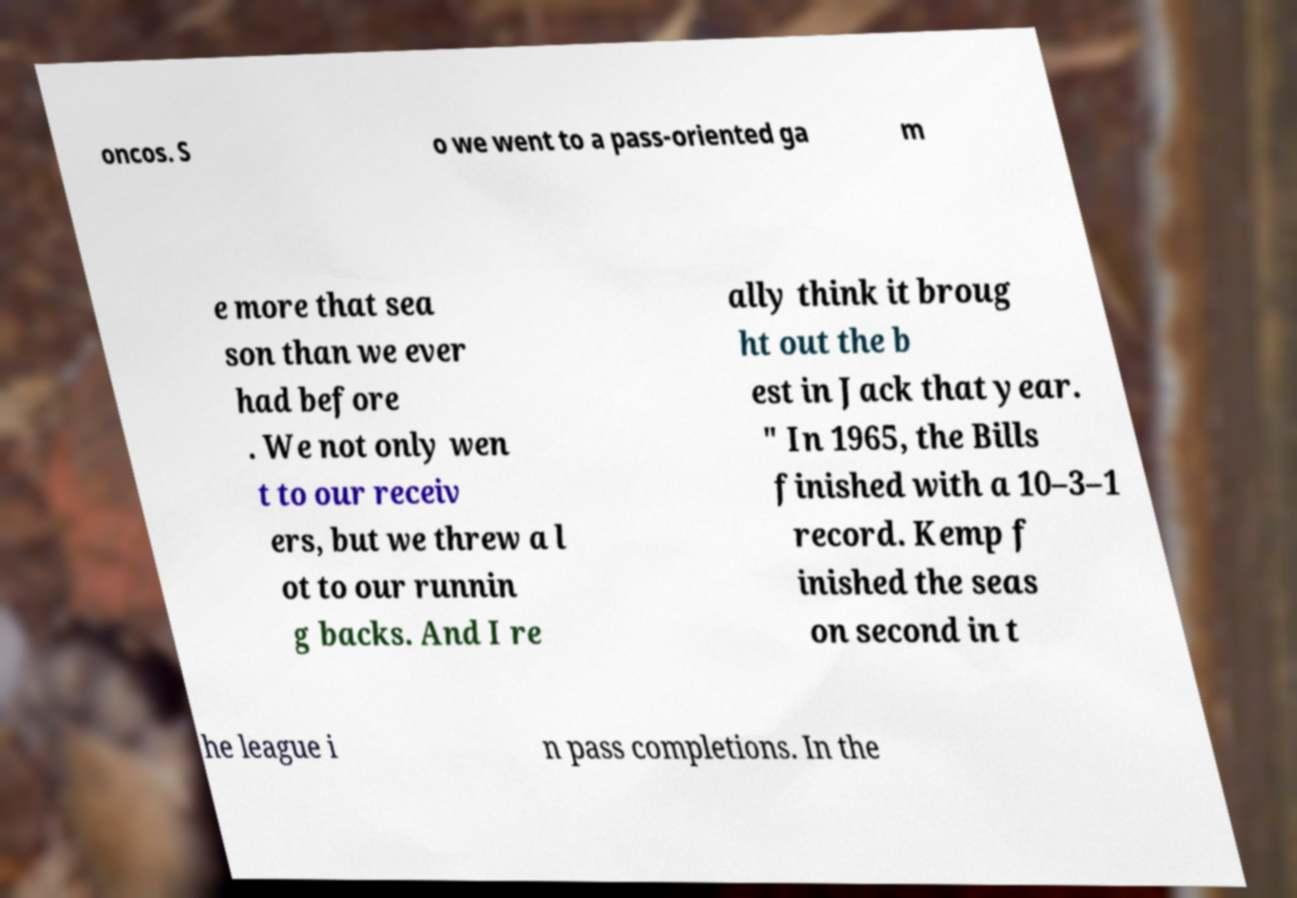For documentation purposes, I need the text within this image transcribed. Could you provide that? oncos. S o we went to a pass-oriented ga m e more that sea son than we ever had before . We not only wen t to our receiv ers, but we threw a l ot to our runnin g backs. And I re ally think it broug ht out the b est in Jack that year. " In 1965, the Bills finished with a 10–3–1 record. Kemp f inished the seas on second in t he league i n pass completions. In the 